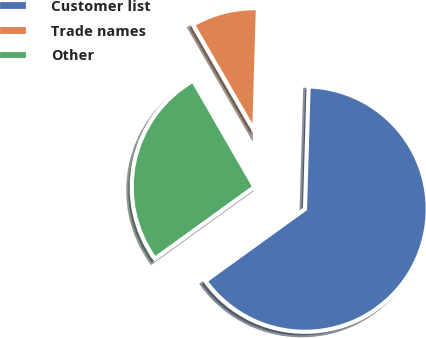Convert chart to OTSL. <chart><loc_0><loc_0><loc_500><loc_500><pie_chart><fcel>Customer list<fcel>Trade names<fcel>Other<nl><fcel>64.58%<fcel>8.8%<fcel>26.62%<nl></chart> 